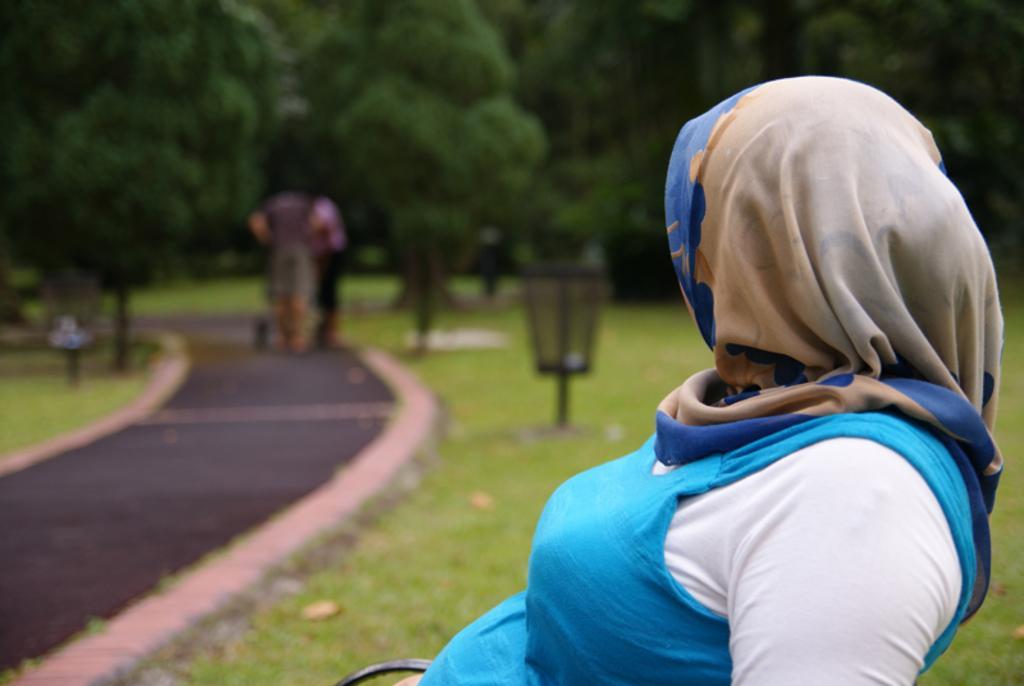Please provide a concise description of this image. In this picture we can observe a woman wearing blue and white color dress, sitting on the bench. There is a path. In the background there are trees. 